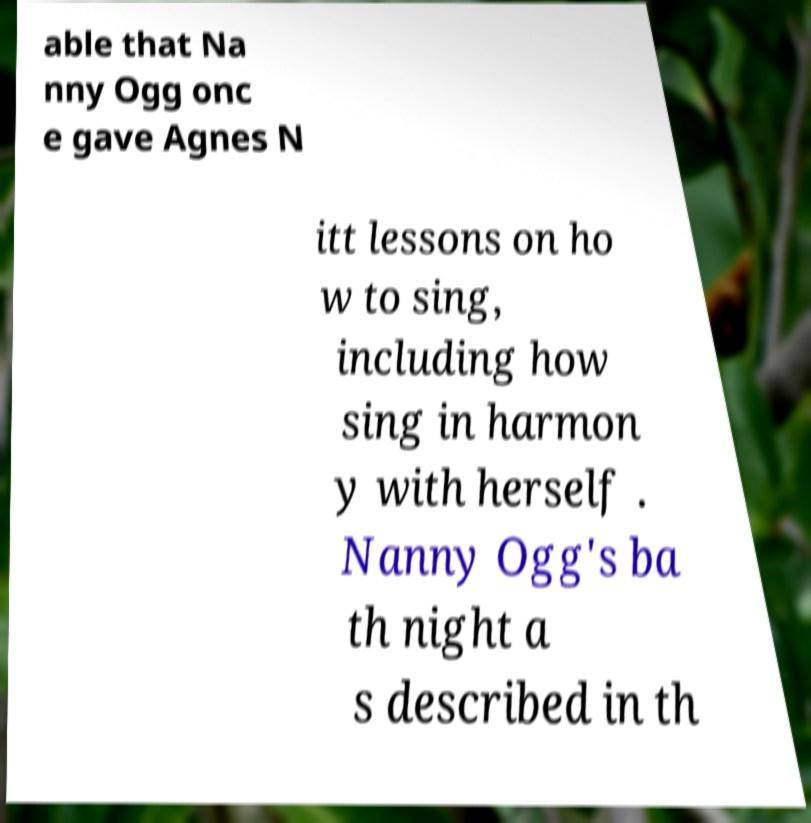Please read and relay the text visible in this image. What does it say? able that Na nny Ogg onc e gave Agnes N itt lessons on ho w to sing, including how sing in harmon y with herself . Nanny Ogg's ba th night a s described in th 